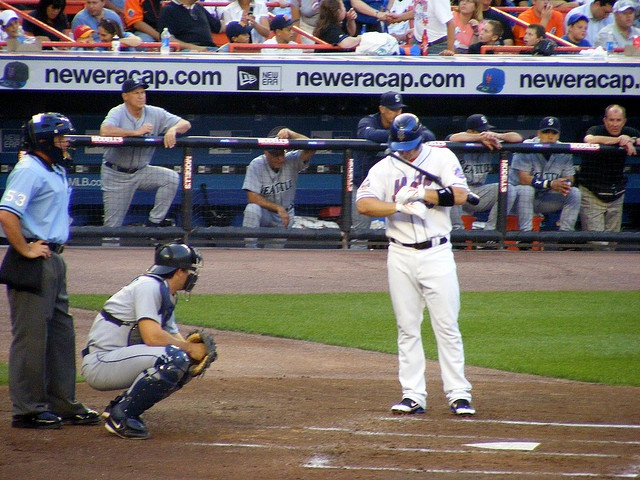Describe the objects in this image and their specific colors. I can see people in salmon, black, gray, brown, and lightgray tones, people in salmon, white, darkgray, black, and gray tones, people in salmon, black, lightblue, and navy tones, people in salmon, black, darkgray, gray, and lightgray tones, and people in salmon, gray, darkgray, and black tones in this image. 